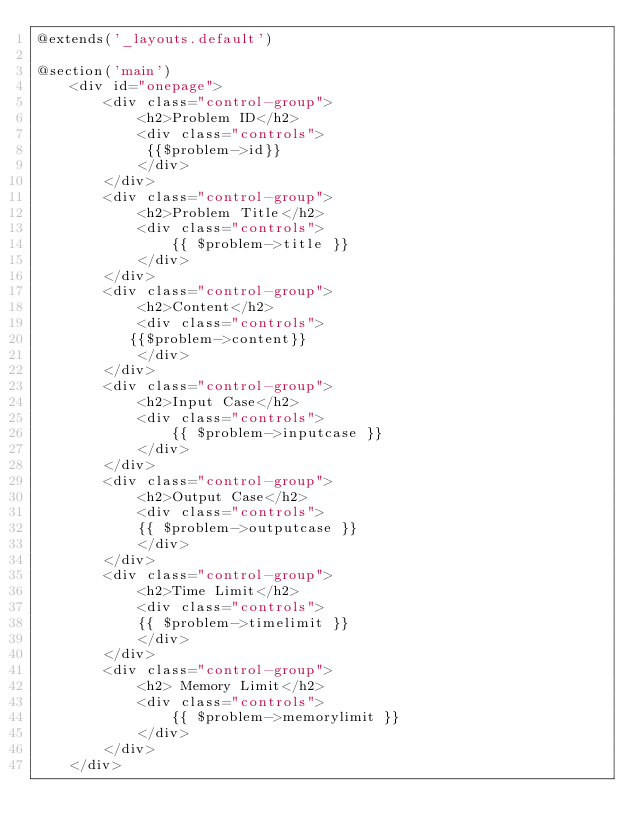<code> <loc_0><loc_0><loc_500><loc_500><_PHP_>@extends('_layouts.default')

@section('main')
    <div id="onepage">
        <div class="control-group">
            <h2>Problem ID</h2>
            <div class="controls">
             {{$problem->id}}
            </div>
        </div>
        <div class="control-group">
            <h2>Problem Title</h2>
            <div class="controls">
                {{ $problem->title }}
            </div>
        </div>
        <div class="control-group">
            <h2>Content</h2>
            <div class="controls">
           {{$problem->content}}
            </div>
        </div>
        <div class="control-group">
            <h2>Input Case</h2>
            <div class="controls">
                {{ $problem->inputcase }}
            </div>
        </div>
        <div class="control-group">
            <h2>Output Case</h2>
            <div class="controls">
            {{ $problem->outputcase }}
            </div>
        </div>
        <div class="control-group">
            <h2>Time Limit</h2>
            <div class="controls">
            {{ $problem->timelimit }}
            </div>
        </div>
        <div class="control-group">
            <h2> Memory Limit</h2>
            <div class="controls">
                {{ $problem->memorylimit }}
            </div>
        </div>
    </div></code> 